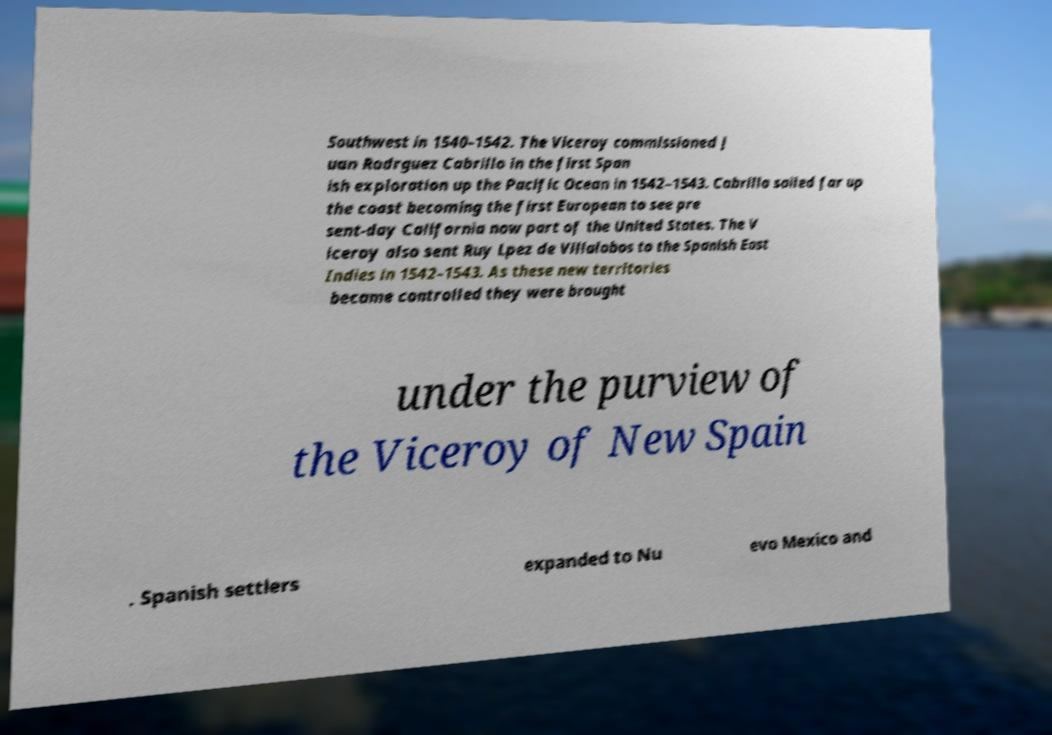Can you read and provide the text displayed in the image?This photo seems to have some interesting text. Can you extract and type it out for me? Southwest in 1540–1542. The Viceroy commissioned J uan Rodrguez Cabrillo in the first Span ish exploration up the Pacific Ocean in 1542–1543. Cabrillo sailed far up the coast becoming the first European to see pre sent-day California now part of the United States. The V iceroy also sent Ruy Lpez de Villalobos to the Spanish East Indies in 1542–1543. As these new territories became controlled they were brought under the purview of the Viceroy of New Spain . Spanish settlers expanded to Nu evo Mexico and 